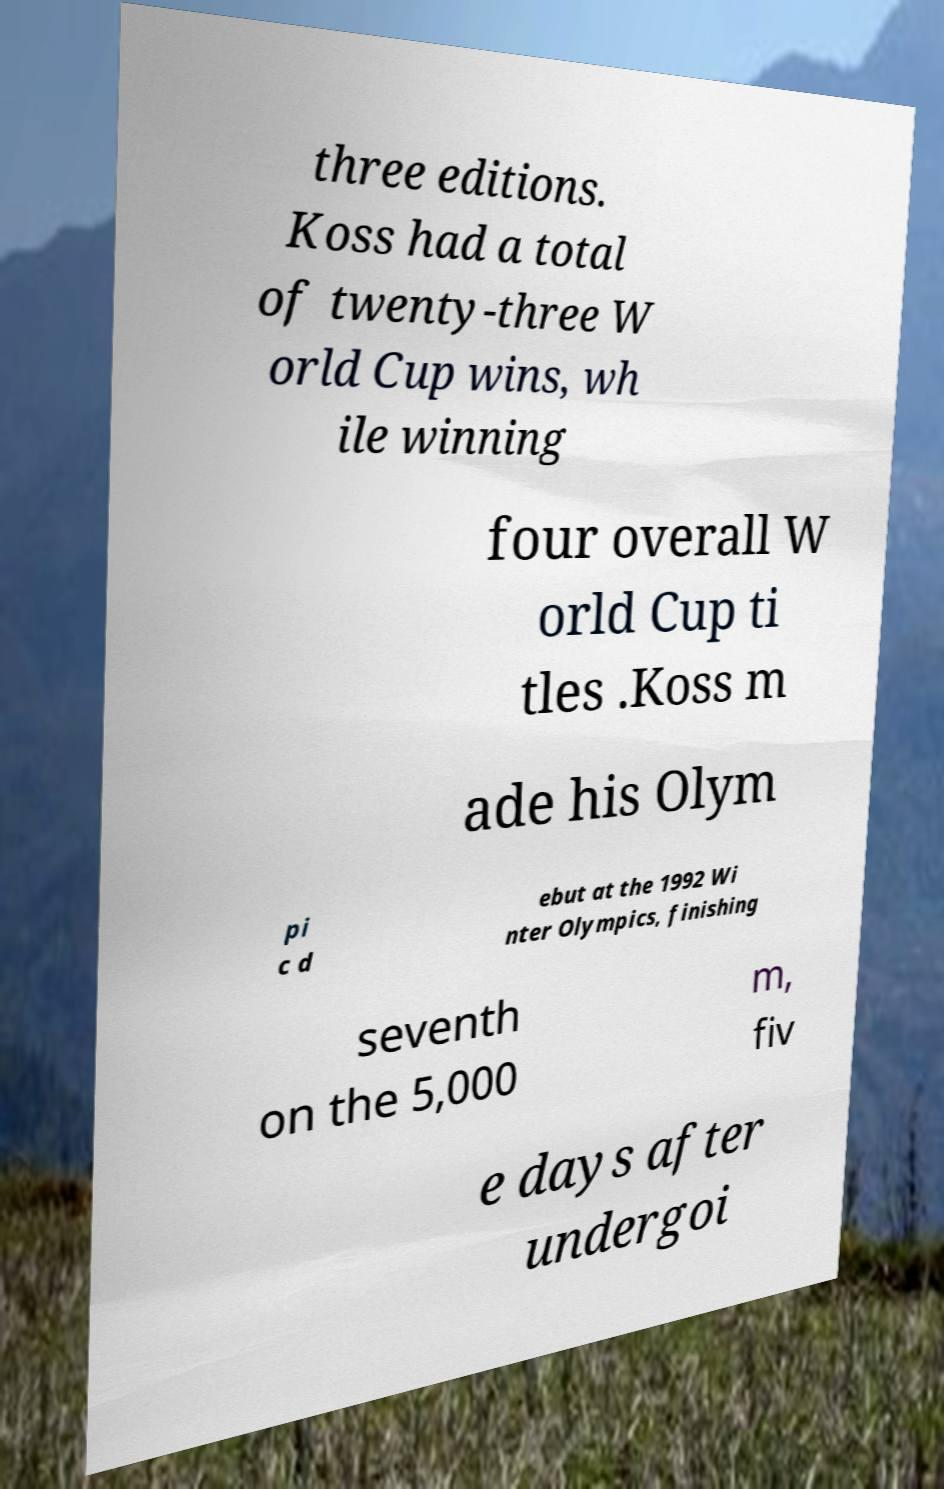Please read and relay the text visible in this image. What does it say? three editions. Koss had a total of twenty-three W orld Cup wins, wh ile winning four overall W orld Cup ti tles .Koss m ade his Olym pi c d ebut at the 1992 Wi nter Olympics, finishing seventh on the 5,000 m, fiv e days after undergoi 